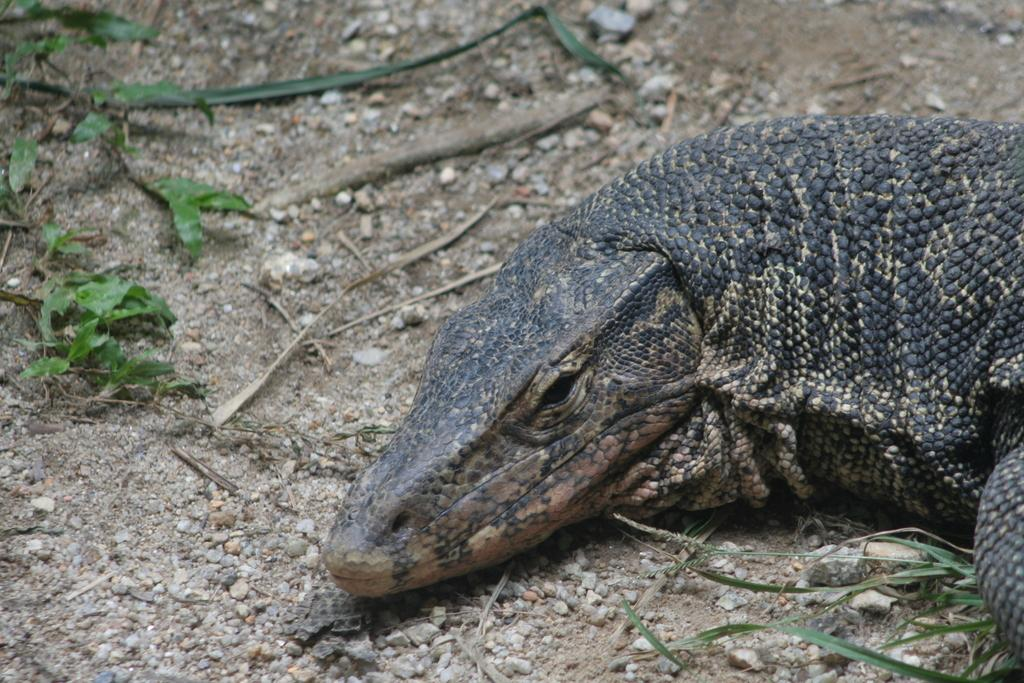What type of animal is in the image? There is a reptile in the image. What colors can be seen on the reptile? The reptile is black and cream in color. Where is the reptile located in the image? The reptile is on the ground. What else can be seen on the ground in the image? There are small stones on the ground. What type of vegetation is present in the image? There are plants in the image. What type of ink is being used by the representative in the image? There is no representative or ink present in the image; it features a reptile on the ground with small stones and plants. 